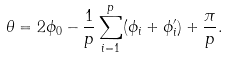Convert formula to latex. <formula><loc_0><loc_0><loc_500><loc_500>\theta = 2 \phi _ { 0 } - \frac { 1 } { p } \sum _ { i = 1 } ^ { p } ( \phi _ { i } + \phi ^ { \prime } _ { i } ) + \frac { \pi } { p } .</formula> 